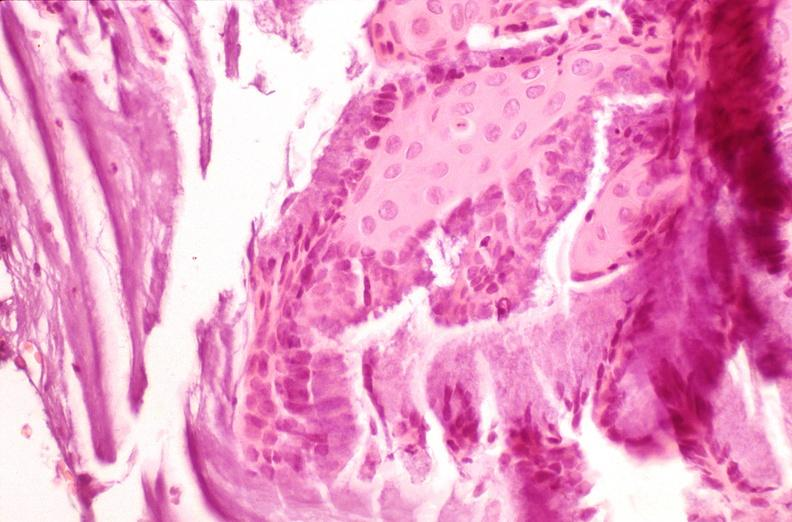what does this image show?
Answer the question using a single word or phrase. Cervix 